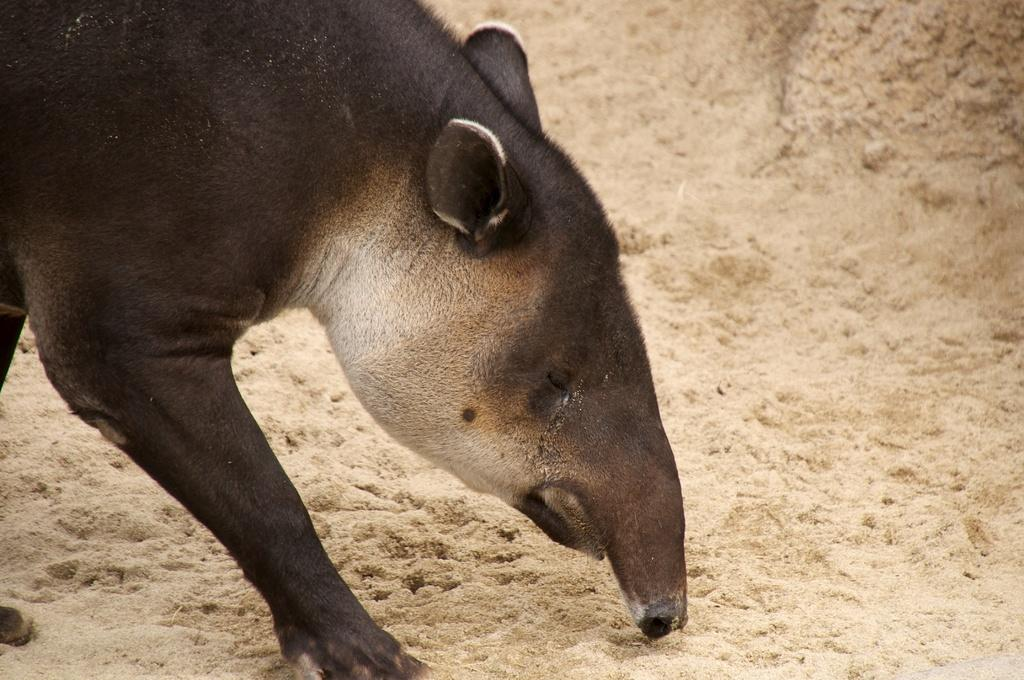What type of animal is in the image? The specific type of animal cannot be determined from the provided facts. What can be seen in the background of the image? There is sand visible in the background of the image. How many creatures are jumping in the image? There is no information about creatures or jumping in the image; it only mentions an animal and sand in the background. 